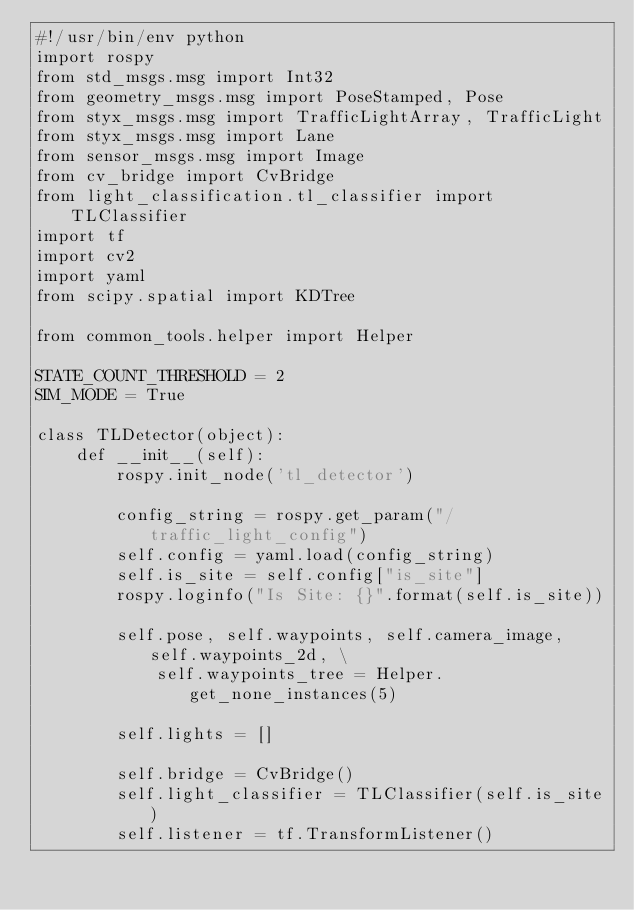Convert code to text. <code><loc_0><loc_0><loc_500><loc_500><_Python_>#!/usr/bin/env python
import rospy
from std_msgs.msg import Int32
from geometry_msgs.msg import PoseStamped, Pose
from styx_msgs.msg import TrafficLightArray, TrafficLight
from styx_msgs.msg import Lane
from sensor_msgs.msg import Image
from cv_bridge import CvBridge
from light_classification.tl_classifier import TLClassifier
import tf
import cv2
import yaml
from scipy.spatial import KDTree

from common_tools.helper import Helper

STATE_COUNT_THRESHOLD = 2
SIM_MODE = True

class TLDetector(object):
    def __init__(self):
        rospy.init_node('tl_detector')

        config_string = rospy.get_param("/traffic_light_config")
        self.config = yaml.load(config_string)
        self.is_site = self.config["is_site"]
        rospy.loginfo("Is Site: {}".format(self.is_site))

        self.pose, self.waypoints, self.camera_image, self.waypoints_2d, \
            self.waypoints_tree = Helper.get_none_instances(5)

        self.lights = []

        self.bridge = CvBridge()
        self.light_classifier = TLClassifier(self.is_site)
        self.listener = tf.TransformListener()
</code> 